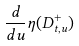<formula> <loc_0><loc_0><loc_500><loc_500>\frac { d } { d u } \eta ( D ^ { + } _ { t , u } )</formula> 